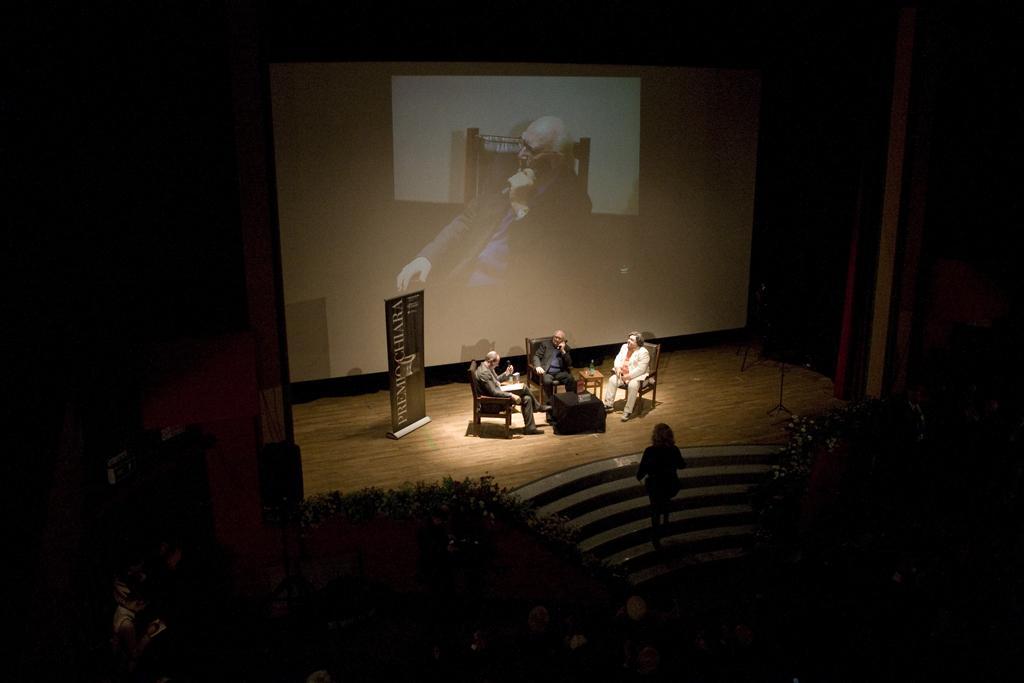Can you describe this image briefly? In the center of the image we can see three people sitting. There are stands and we can see a bottle placed on the stand. There is a banner. In the background we can see a screen. At the bottom there are people and we can see stairs. There are plants and we can see flowers. 